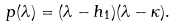Convert formula to latex. <formula><loc_0><loc_0><loc_500><loc_500>p ( \lambda ) = ( \lambda - h _ { 1 } ) ( \lambda - \kappa ) .</formula> 